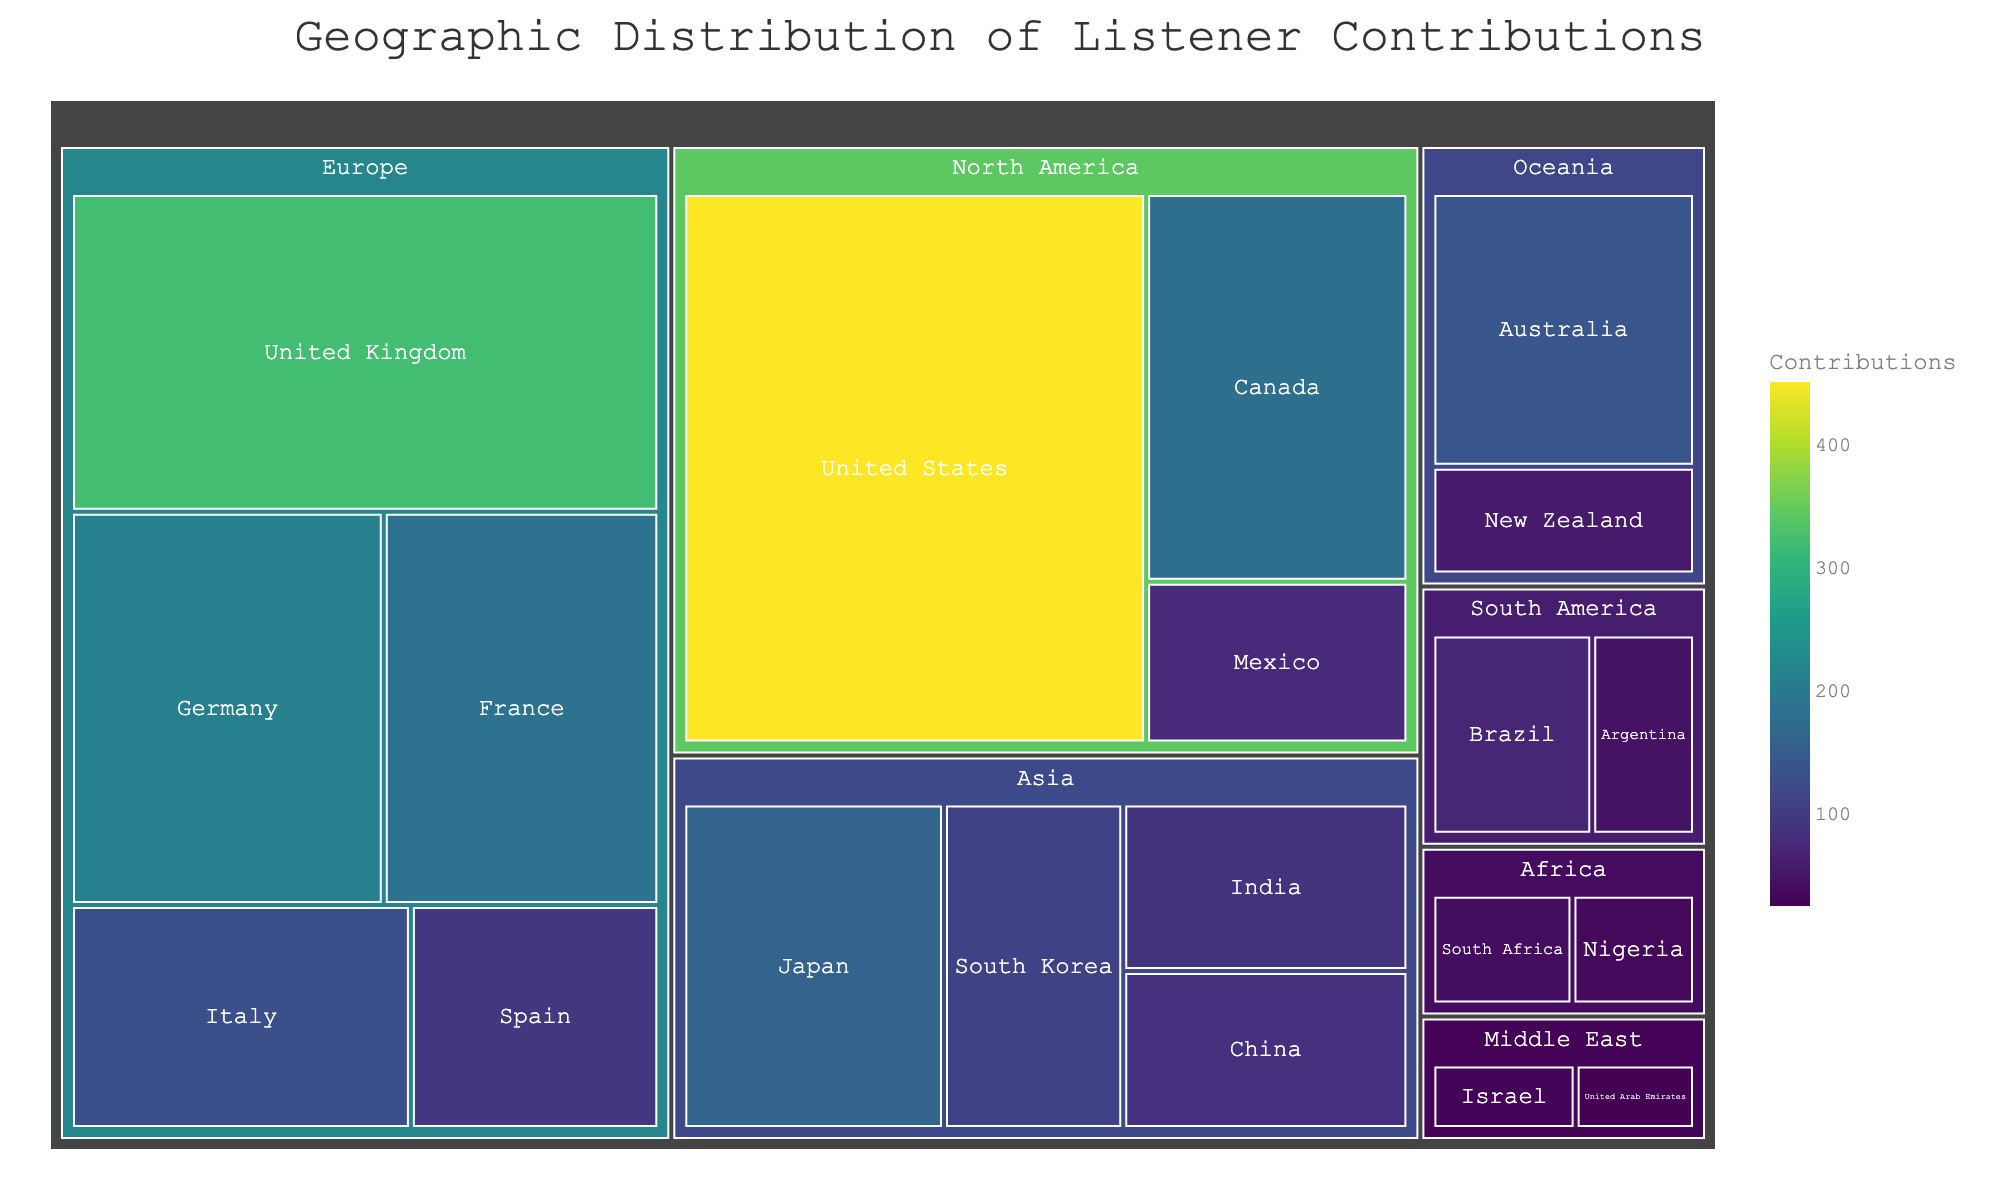what is the title of the figure? The title is located at the top of the figure and is visually clear with larger text. It provides a summary of what the figure is about.
Answer: Geographic Distribution of Listener Contributions Which country has the highest number of contributions? By examining the largest rectangle in the treemap, which represents the country with the most contributions, we can determine the value.
Answer: United States What is the combined contribution from Canada and Mexico? Locate the areas representing Canada and Mexico in the North America region. Sum their contributions (180 from Canada + 75 from Mexico).
Answer: 255 Which region has the least number of contributions? Identify the smallest aggregated area among the regions. The smallest rectangle will represent the region with the lowest contributions.
Answer: Middle East How does the United Kingdom's contributions compare to Germany's? Identify and compare the sizes and values within the Europe region for both the United Kingdom and Germany.
Answer: United Kingdom has more contributions than Germany What is the total contribution from the European region? Sum the contributions from all countries in the European region: 320 (UK) + 210 (Germany) + 185 (France) + 130 (Italy) + 95 (Spain).
Answer: 940 Which country in Asia has the highest number of contributions? Examine the rectangles in the Asia region and identify the one with the largest value.
Answer: Japan How do contributions from Oceania compare to South America? Sum the contributions from the countries in each region: Oceania (Australia + New Zealand) and South America (Brazil + Argentina). Compare the totals.
Answer: Oceania has more contributions than South America What is the average number of contributions per country in the Middle East? Sum the contributions from the Middle East countries (Israel + United Arab Emirates) and divide by the number of countries. (30 + 25) / 2.
Answer: 27.5 Which region is more diverse in contributions, Africa or South America? Compare the variety and number of countries and their contributions within each region by looking at the subdivisions in their respective rectangles.
Answer: South America 